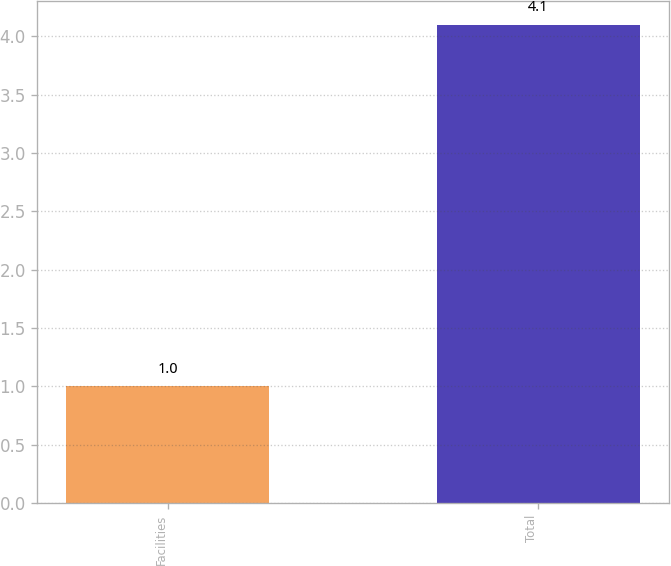Convert chart to OTSL. <chart><loc_0><loc_0><loc_500><loc_500><bar_chart><fcel>Facilities<fcel>Total<nl><fcel>1<fcel>4.1<nl></chart> 